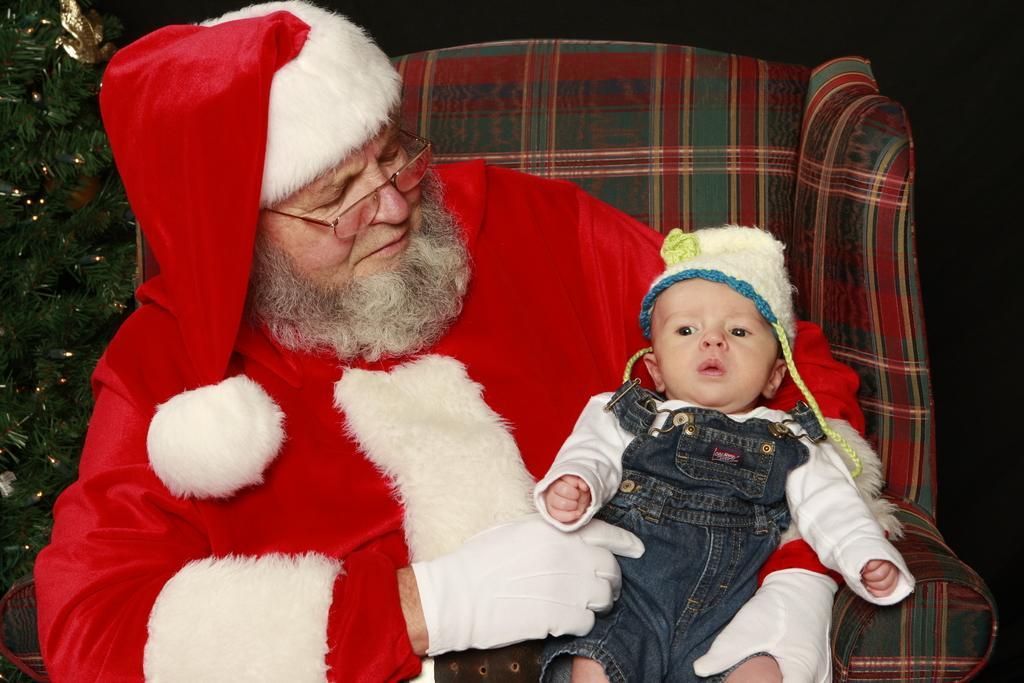Can you describe this image briefly? In the picture we can see a man in a Santa costume sitting on the chair and holding a baby and beside him we can see a part of the decorated tree. 